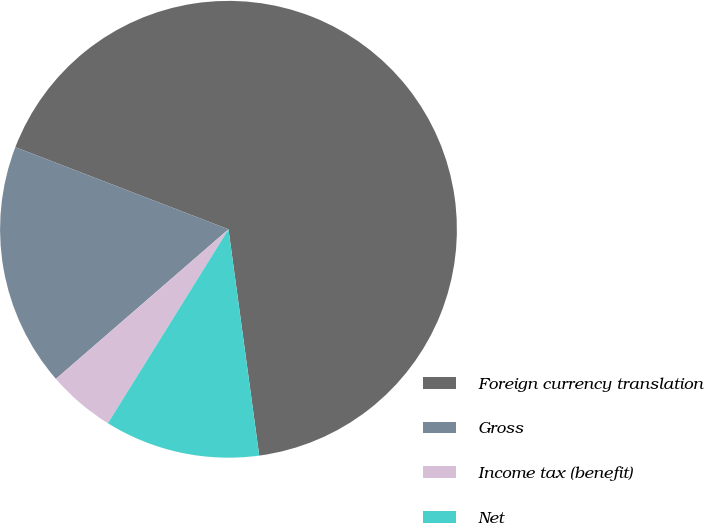Convert chart to OTSL. <chart><loc_0><loc_0><loc_500><loc_500><pie_chart><fcel>Foreign currency translation<fcel>Gross<fcel>Income tax (benefit)<fcel>Net<nl><fcel>66.99%<fcel>17.22%<fcel>4.78%<fcel>11.0%<nl></chart> 